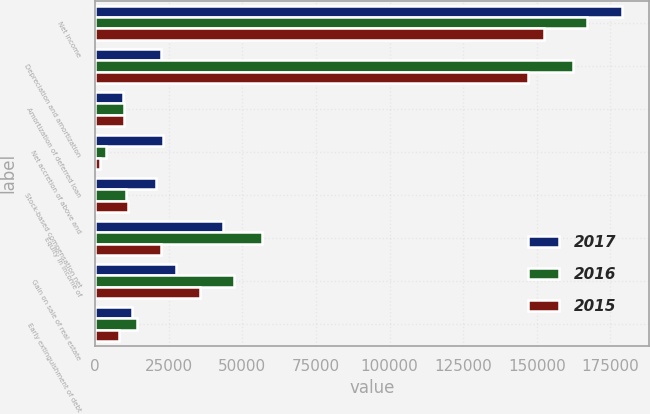Convert chart to OTSL. <chart><loc_0><loc_0><loc_500><loc_500><stacked_bar_chart><ecel><fcel>Net income<fcel>Depreciation and amortization<fcel>Amortization of deferred loan<fcel>Net accretion of above and<fcel>Stock-based compensation net<fcel>Equity in income of<fcel>Gain on sale of real estate<fcel>Early extinguishment of debt<nl><fcel>2017<fcel>178980<fcel>22508<fcel>9509<fcel>23144<fcel>20549<fcel>43341<fcel>27432<fcel>12449<nl><fcel>2016<fcel>166992<fcel>162327<fcel>9762<fcel>3879<fcel>10652<fcel>56518<fcel>47321<fcel>14240<nl><fcel>2015<fcel>152543<fcel>146829<fcel>9677<fcel>1598<fcel>11081<fcel>22508<fcel>35606<fcel>8239<nl></chart> 